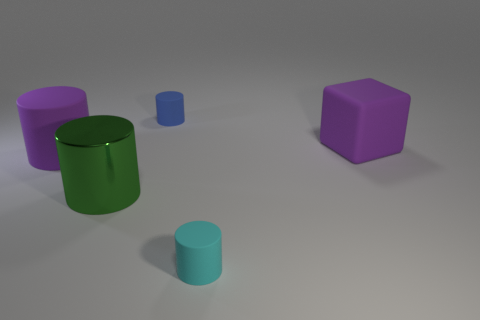Subtract all large green metal cylinders. How many cylinders are left? 3 Add 5 tiny cyan cylinders. How many objects exist? 10 Subtract all cyan cylinders. How many cylinders are left? 3 Subtract all blocks. How many objects are left? 4 Subtract all cyan cylinders. Subtract all gray blocks. How many cylinders are left? 3 Add 3 tiny cylinders. How many tiny cylinders exist? 5 Subtract 0 brown cylinders. How many objects are left? 5 Subtract all large red rubber cubes. Subtract all large objects. How many objects are left? 2 Add 2 big purple blocks. How many big purple blocks are left? 3 